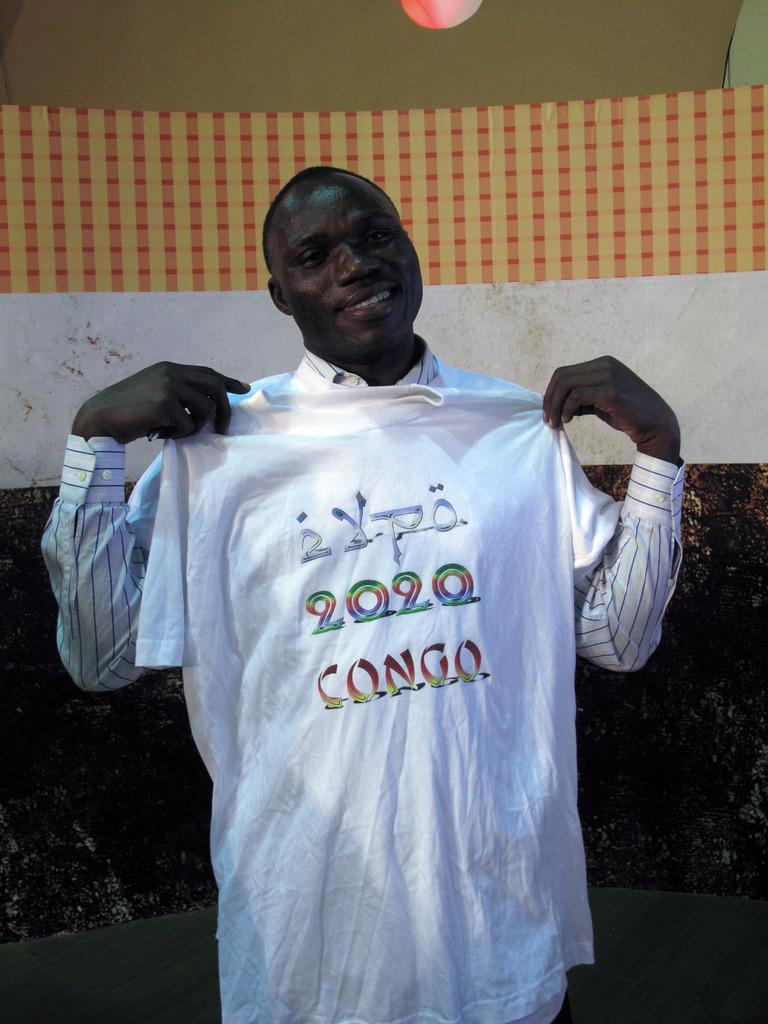<image>
Share a concise interpretation of the image provided. A man is holding up a T shirt with 2020 CONGO written on it. 